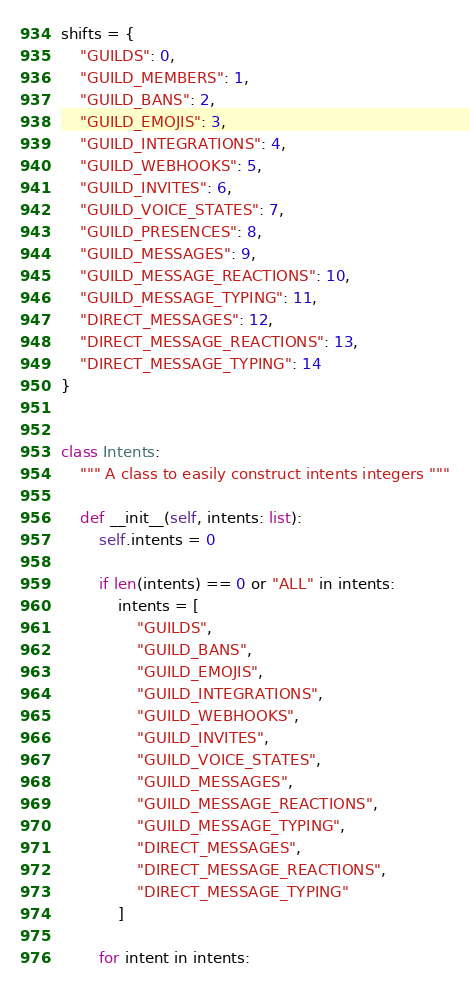Convert code to text. <code><loc_0><loc_0><loc_500><loc_500><_Python_>shifts = {
    "GUILDS": 0,
    "GUILD_MEMBERS": 1,
    "GUILD_BANS": 2,
    "GUILD_EMOJIS": 3,
    "GUILD_INTEGRATIONS": 4,
    "GUILD_WEBHOOKS": 5,
    "GUILD_INVITES": 6,
    "GUILD_VOICE_STATES": 7,
    "GUILD_PRESENCES": 8,
    "GUILD_MESSAGES": 9,
    "GUILD_MESSAGE_REACTIONS": 10,
    "GUILD_MESSAGE_TYPING": 11,
    "DIRECT_MESSAGES": 12,
    "DIRECT_MESSAGE_REACTIONS": 13,
    "DIRECT_MESSAGE_TYPING": 14
}


class Intents:
    """ A class to easily construct intents integers """

    def __init__(self, intents: list):
        self.intents = 0

        if len(intents) == 0 or "ALL" in intents:
            intents = [
                "GUILDS",
                "GUILD_BANS",
                "GUILD_EMOJIS",
                "GUILD_INTEGRATIONS",
                "GUILD_WEBHOOKS",
                "GUILD_INVITES",
                "GUILD_VOICE_STATES",
                "GUILD_MESSAGES",
                "GUILD_MESSAGE_REACTIONS",
                "GUILD_MESSAGE_TYPING",
                "DIRECT_MESSAGES",
                "DIRECT_MESSAGE_REACTIONS",
                "DIRECT_MESSAGE_TYPING"
            ]

        for intent in intents:</code> 